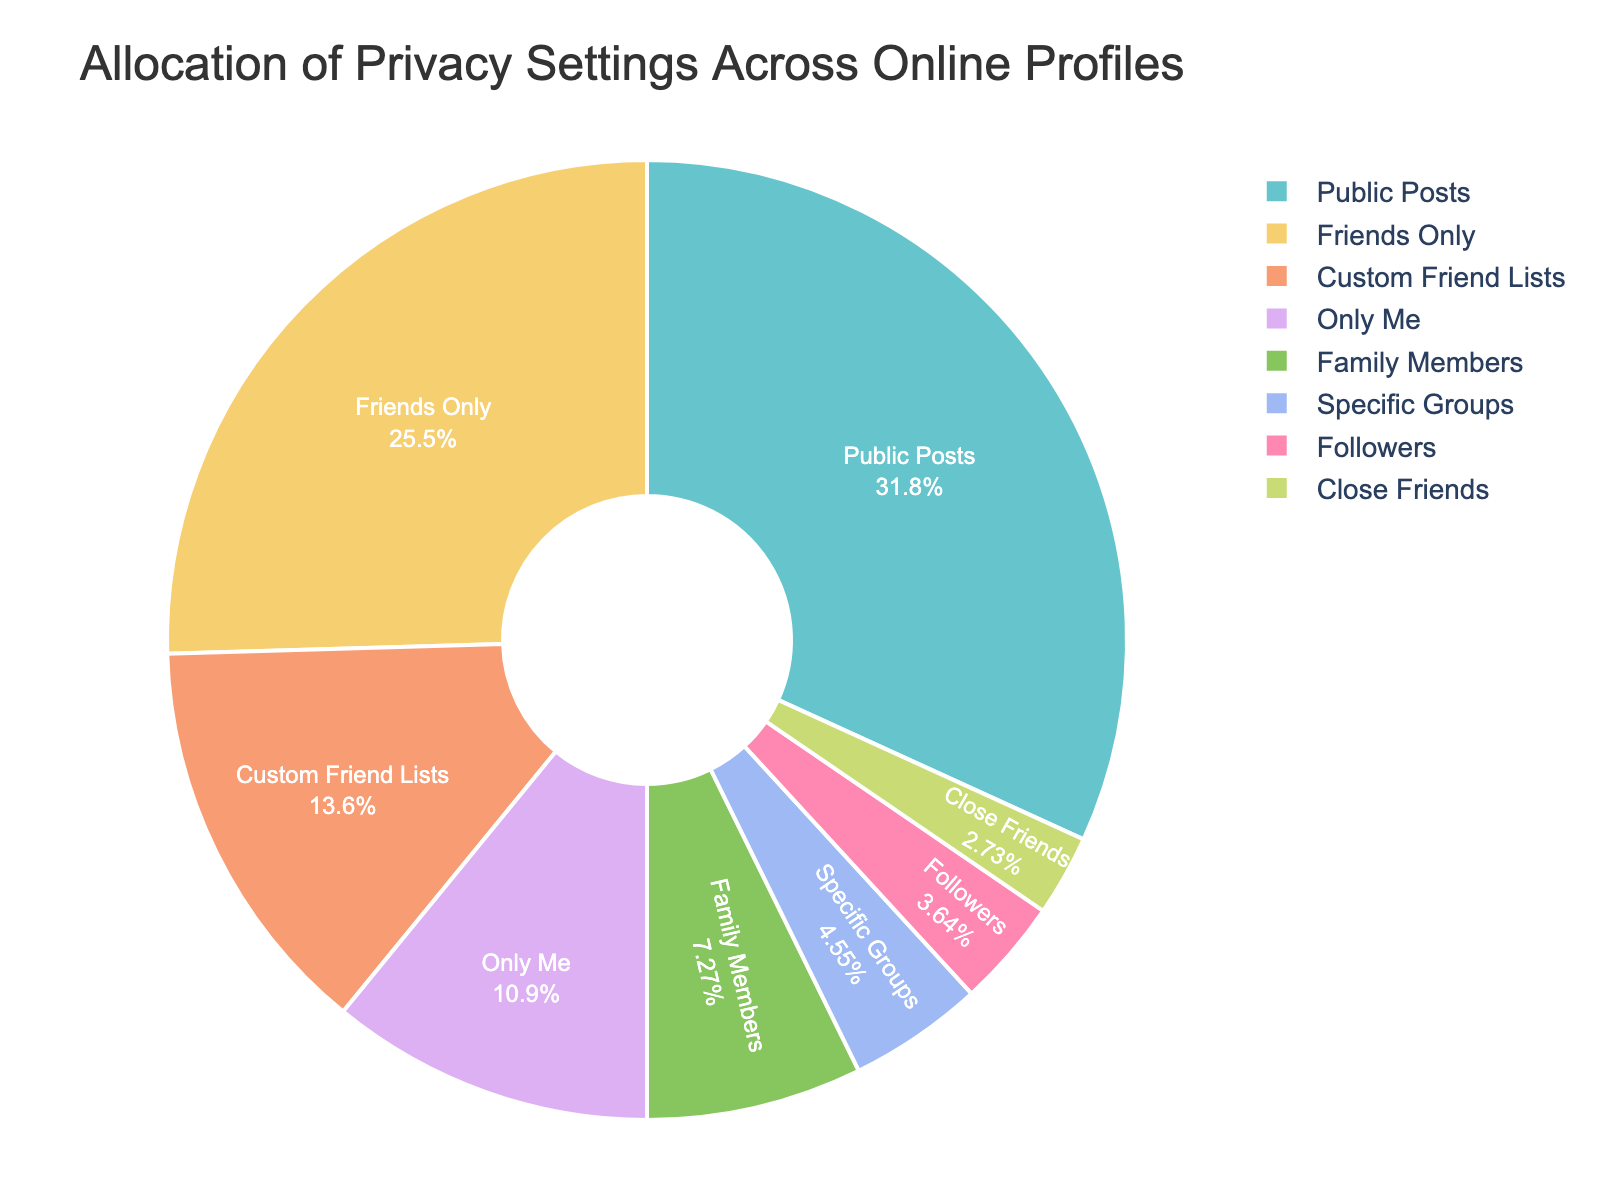What's the largest category in the pie chart? The largest category can be identified by looking for the segment with the highest percentage. In this case, the "Public Posts" segment occupies the largest portion of the pie chart at 35%.
Answer: Public Posts Which two categories have the smallest percentages combined? To find the two categories with the smallest percentages combined, look for the two smallest segments. These are "Close Friends" at 3% and "Followers" at 4%. Adding these together gives 3% + 4% = 7%.
Answer: Close Friends and Followers What is the difference in allocation between "Friends Only" and "Custom Friend Lists"? The percentage for "Friends Only" is 28% and for "Custom Friend Lists" is 15%. The difference is calculated as 28% - 15% = 13%.
Answer: 13% How does the percentage allocation for "Family Members" compare to "Only Me"? The percentage for "Family Members" is 8%, and for "Only Me" it is 12%. Therefore, "Family Members" has a lower allocation than "Only Me".
Answer: Family Members has a lower allocation than Only Me What percentage of privacy settings are allocated to categories where posts are not visible to the general public? To calculate this, sum the percentages of categories excluding "Public Posts". These categories are: Friends Only (28%), Custom Friend Lists (15%), Only Me (12%), Family Members (8%), Specific Groups (5%), Followers (4%), Close Friends (3%). Adding these gives 28% + 15% + 12% + 8% + 5% + 4% + 3% = 75%.
Answer: 75% If you combine the "Specific Groups" and "Custom Friend Lists" categories, what is their total allocation? The percentage for "Specific Groups" is 5% and for "Custom Friend Lists" is 15%. Adding these together gives 5% + 15% = 20%.
Answer: 20% Which category has a greater allocation: "Family Members" or "Followers"? By how much? The percentage for "Family Members" is 8%, and for "Followers" it is 4%. The difference is calculated as 8% - 4% = 4%.
Answer: Family Members by 4% How many categories have an allocation of 10% or higher? To determine this, count the categories with percentages of 10% or more. These categories are "Public Posts" (35%), "Friends Only" (28%), and "Only Me" (12%). There are three categories.
Answer: 3 What's the total allocation for the categories "Friends Only", "Only Me", and "Close Friends"? Add the percentages for "Friends Only" (28%), "Only Me" (12%), and "Close Friends" (3%). The total is 28% + 12% + 3% = 43%.
Answer: 43% 